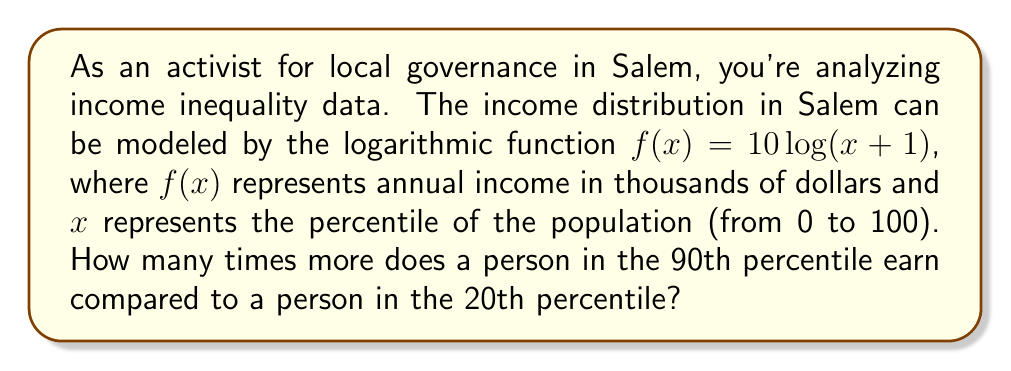Solve this math problem. To solve this problem, we need to follow these steps:

1) First, let's calculate the income for a person in the 90th percentile:
   $f(90) = 10 \log(90+1) = 10 \log(91) \approx 19.59$ thousand dollars

2) Now, let's calculate the income for a person in the 20th percentile:
   $f(20) = 10 log(20+1) = 10 \log(21) \approx 13.22$ thousand dollars

3) To find how many times more the 90th percentile earns compared to the 20th percentile, we need to divide these values:

   $\frac{f(90)}{f(20)} = \frac{19.59}{13.22} \approx 1.48$

This means that a person in the 90th percentile earns approximately 1.48 times more than a person in the 20th percentile.

4) To express this as a percentage increase:
   $(1.48 - 1) \times 100\% = 0.48 \times 100\% = 48\%$

Therefore, a person in the 90th percentile earns about 48% more than a person in the 20th percentile.
Answer: A person in the 90th percentile earns approximately 1.48 times more (or 48% more) than a person in the 20th percentile. 